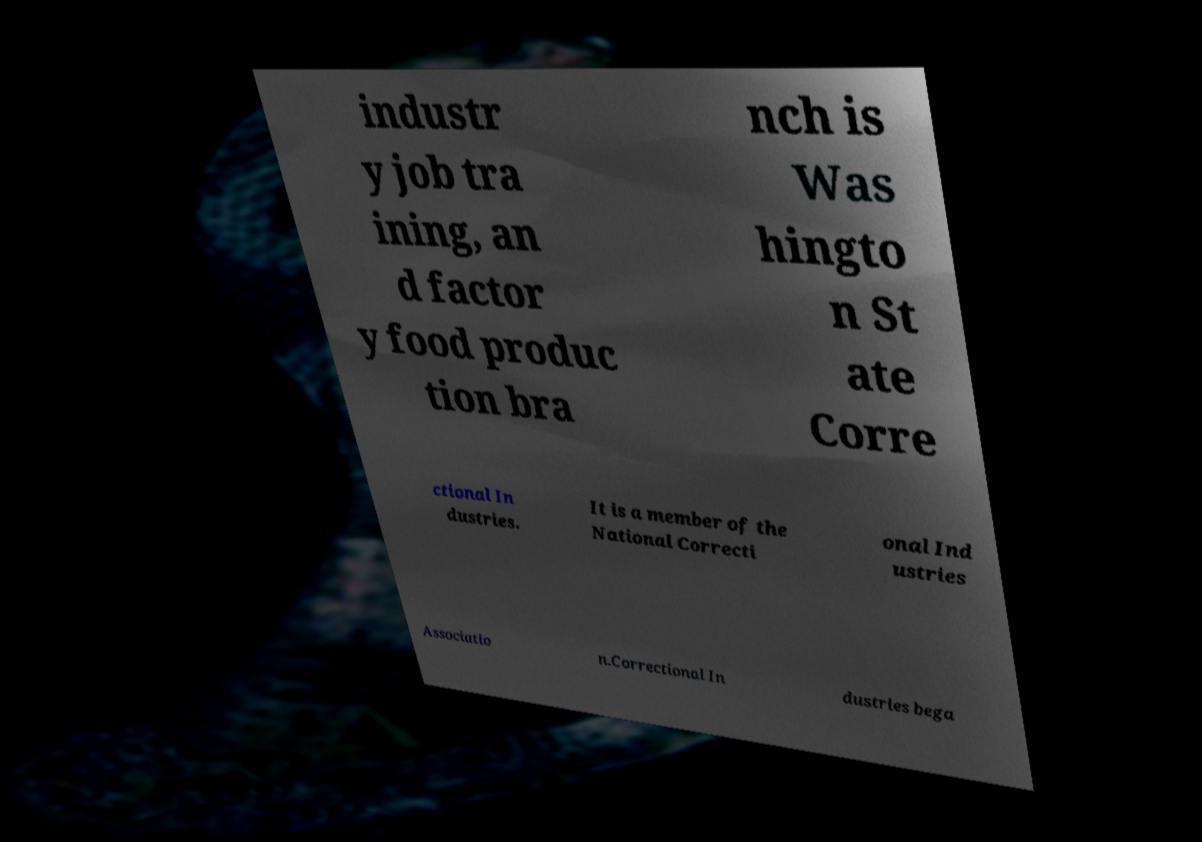What messages or text are displayed in this image? I need them in a readable, typed format. industr y job tra ining, an d factor y food produc tion bra nch is Was hingto n St ate Corre ctional In dustries. It is a member of the National Correcti onal Ind ustries Associatio n.Correctional In dustries bega 